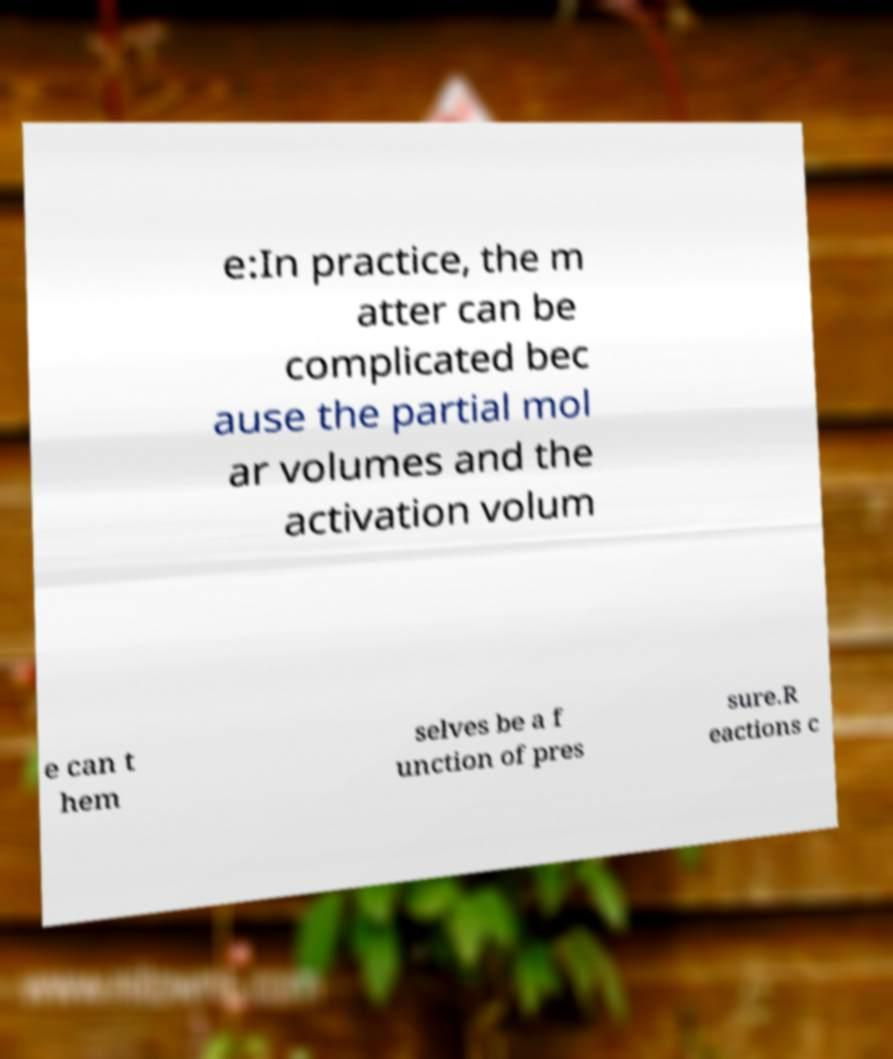Could you extract and type out the text from this image? e:In practice, the m atter can be complicated bec ause the partial mol ar volumes and the activation volum e can t hem selves be a f unction of pres sure.R eactions c 